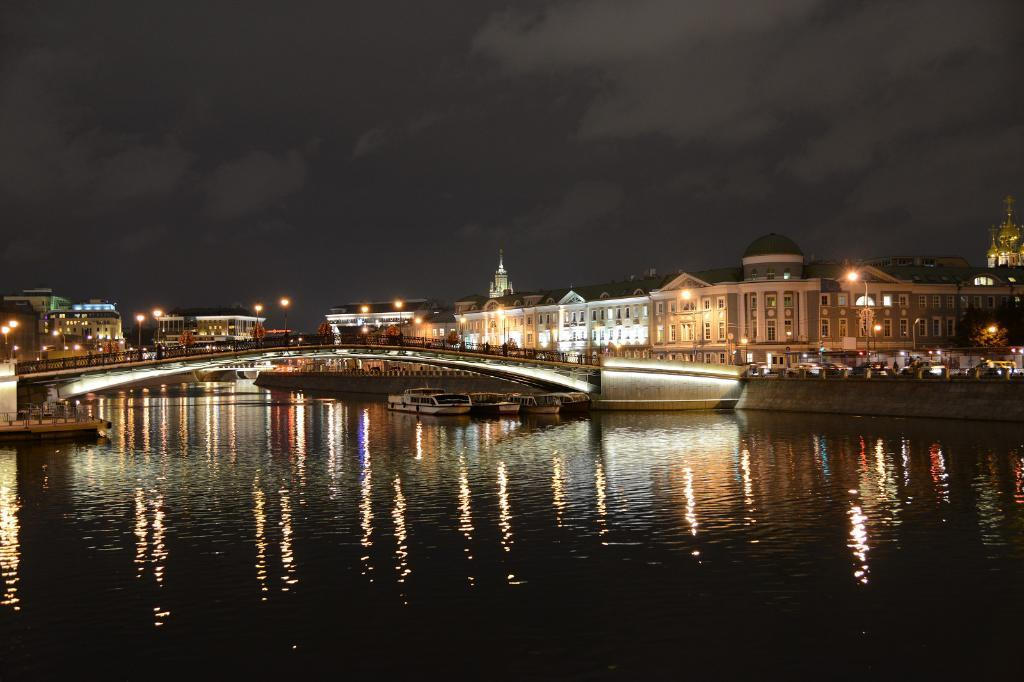What type of structures can be seen in the image? There are buildings in the image. What type of lighting is present in the image? Electric lights are present in the image. What type of street furniture can be seen in the image? Street poles are visible in the image. What type of vehicles can be seen in the image? Boats are in the image. What type of man-made structure is present in the image? There is a bridge in the image. What type of natural feature is visible in the image? A river is visible in the image. What part of the natural environment is visible in the image? The sky is visible in the image. What type of weather can be inferred from the image? Clouds are present in the sky, suggesting that it might be a partly cloudy day. How many friends are visible in the image? There is no reference to friends in the image; it features buildings, electric lights, street poles, boats, a bridge, a river, the sky, and clouds. What type of body part can be seen on the boats in the image? There are no body parts visible on the boats in the image. 